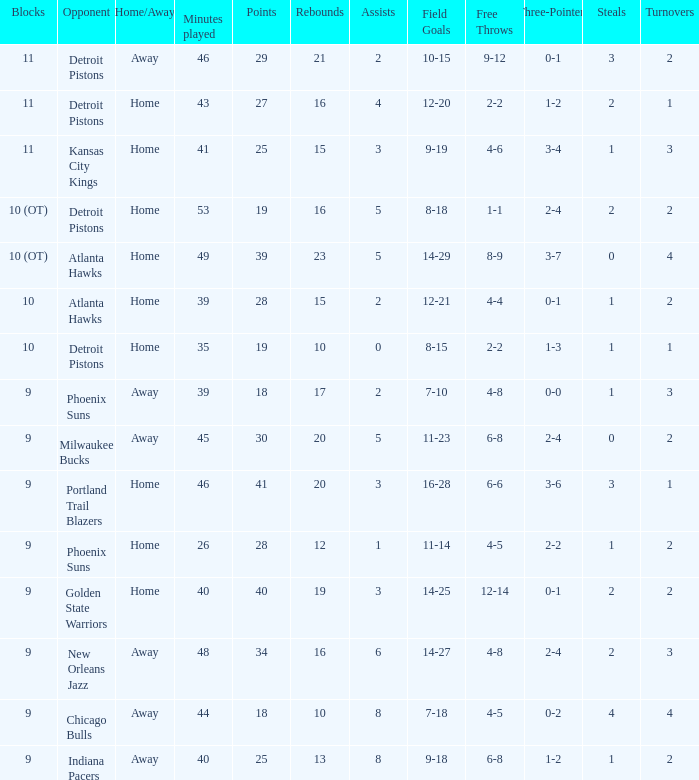How many points were there when there were less than 16 rebounds and 5 assists? 0.0. 